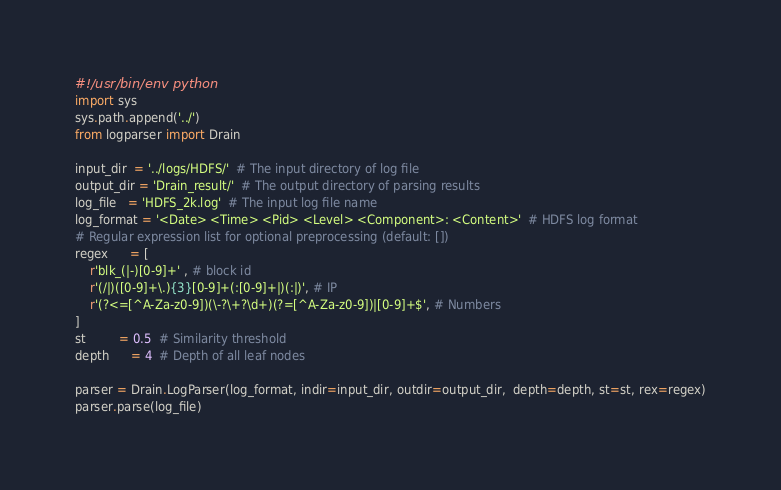Convert code to text. <code><loc_0><loc_0><loc_500><loc_500><_Python_>#!/usr/bin/env python
import sys
sys.path.append('../')
from logparser import Drain

input_dir  = '../logs/HDFS/'  # The input directory of log file
output_dir = 'Drain_result/'  # The output directory of parsing results
log_file   = 'HDFS_2k.log'  # The input log file name
log_format = '<Date> <Time> <Pid> <Level> <Component>: <Content>'  # HDFS log format
# Regular expression list for optional preprocessing (default: [])
regex      = [
    r'blk_(|-)[0-9]+' , # block id
    r'(/|)([0-9]+\.){3}[0-9]+(:[0-9]+|)(:|)', # IP
    r'(?<=[^A-Za-z0-9])(\-?\+?\d+)(?=[^A-Za-z0-9])|[0-9]+$', # Numbers
]
st         = 0.5  # Similarity threshold
depth      = 4  # Depth of all leaf nodes

parser = Drain.LogParser(log_format, indir=input_dir, outdir=output_dir,  depth=depth, st=st, rex=regex)
parser.parse(log_file)

</code> 